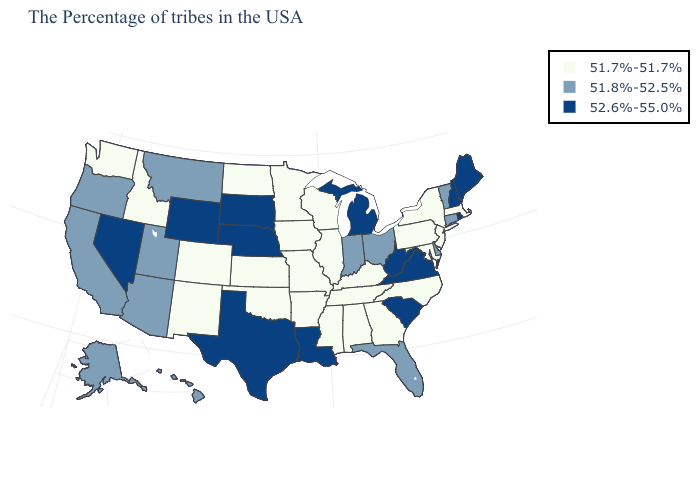Does Kentucky have the lowest value in the South?
Short answer required. Yes. What is the lowest value in the USA?
Short answer required. 51.7%-51.7%. Name the states that have a value in the range 52.6%-55.0%?
Keep it brief. Maine, Rhode Island, New Hampshire, Virginia, South Carolina, West Virginia, Michigan, Louisiana, Nebraska, Texas, South Dakota, Wyoming, Nevada. What is the highest value in the USA?
Concise answer only. 52.6%-55.0%. What is the value of Wisconsin?
Answer briefly. 51.7%-51.7%. Does Wyoming have the highest value in the West?
Short answer required. Yes. Does Tennessee have the lowest value in the South?
Give a very brief answer. Yes. Does Alabama have a higher value than Alaska?
Concise answer only. No. Does Kansas have the lowest value in the MidWest?
Answer briefly. Yes. What is the value of South Carolina?
Short answer required. 52.6%-55.0%. What is the highest value in states that border Florida?
Short answer required. 51.7%-51.7%. Among the states that border Virginia , does West Virginia have the highest value?
Concise answer only. Yes. What is the value of Wisconsin?
Answer briefly. 51.7%-51.7%. Does Alabama have a lower value than Arizona?
Short answer required. Yes. Name the states that have a value in the range 51.7%-51.7%?
Concise answer only. Massachusetts, New York, New Jersey, Maryland, Pennsylvania, North Carolina, Georgia, Kentucky, Alabama, Tennessee, Wisconsin, Illinois, Mississippi, Missouri, Arkansas, Minnesota, Iowa, Kansas, Oklahoma, North Dakota, Colorado, New Mexico, Idaho, Washington. 